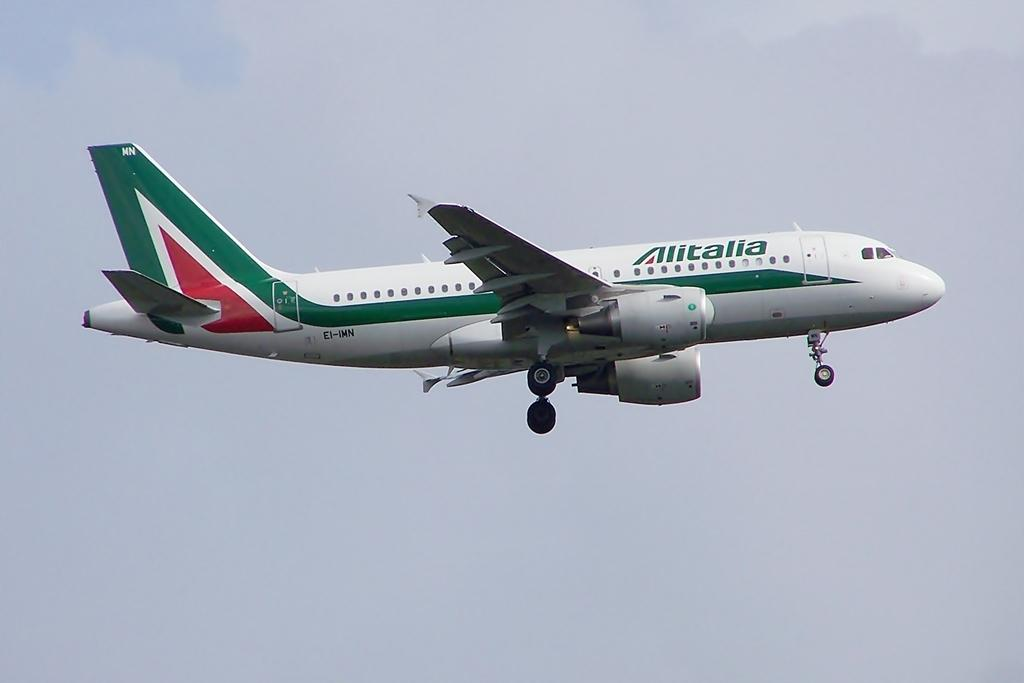<image>
Share a concise interpretation of the image provided. a plane with the word alitalia on the side of it. 